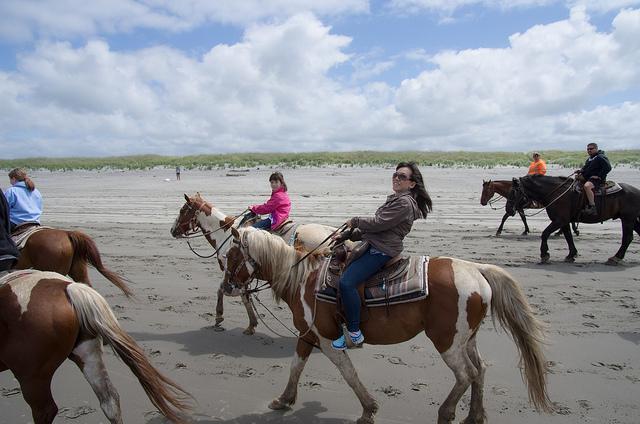How many dark brown horses are in the photo?
Give a very brief answer. 2. How many horses can be seen?
Give a very brief answer. 5. 